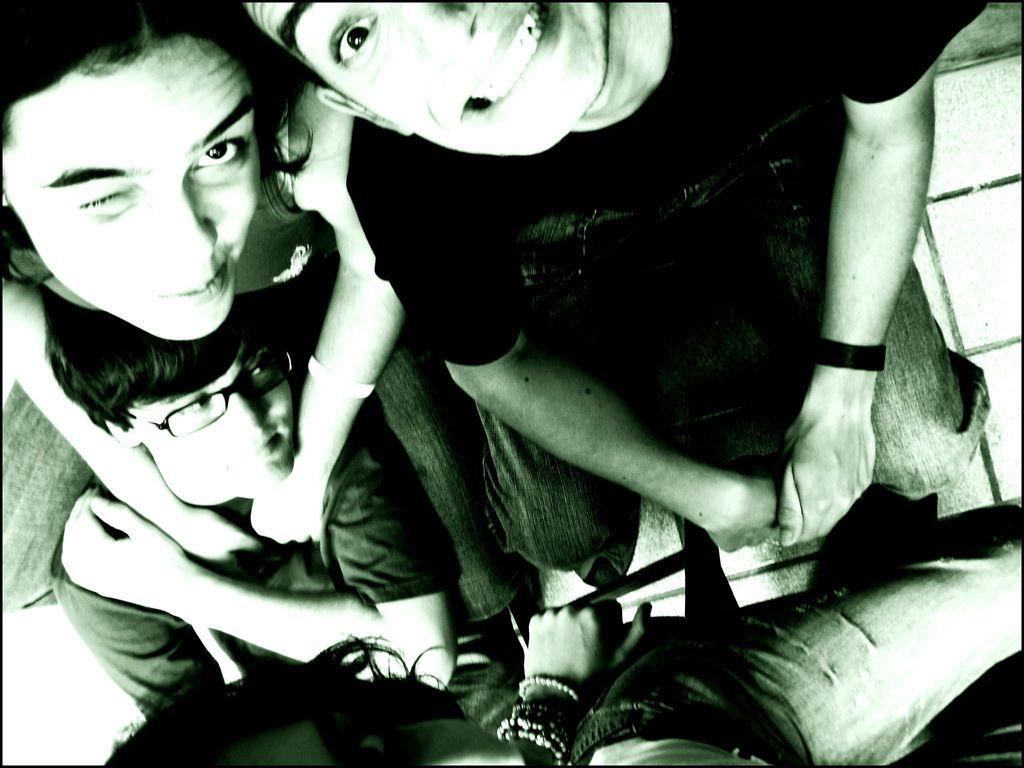What is the color scheme of the image? The image is black and white. How many people are present in the image? There are four people in the image. What are the positions of the people in the image? Three of the people are sitting, and one person is standing. What type of food is being served to the people in the image? There is no food present in the image; it is a black and white image of four people, with three sitting and one standing. 